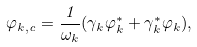Convert formula to latex. <formula><loc_0><loc_0><loc_500><loc_500>\varphi _ { { k } , c } = \frac { 1 } { \omega _ { k } } ( \gamma _ { k } \varphi _ { k } ^ { * } + \gamma _ { k } ^ { * } \varphi _ { k } ) ,</formula> 